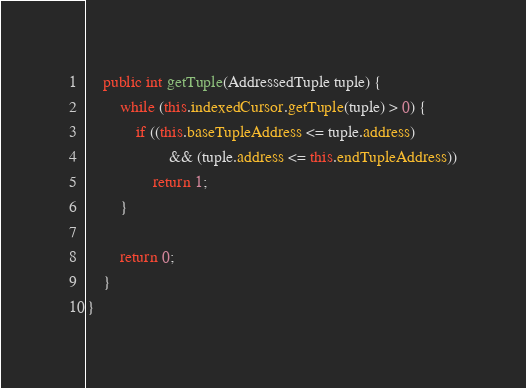Convert code to text. <code><loc_0><loc_0><loc_500><loc_500><_Java_>
	public int getTuple(AddressedTuple tuple) {		
		while (this.indexedCursor.getTuple(tuple) > 0) {
			if ((this.baseTupleAddress <= tuple.address) 
					&& (tuple.address <= this.endTupleAddress))
				return 1;
		}

		return 0;
	}
}
</code> 